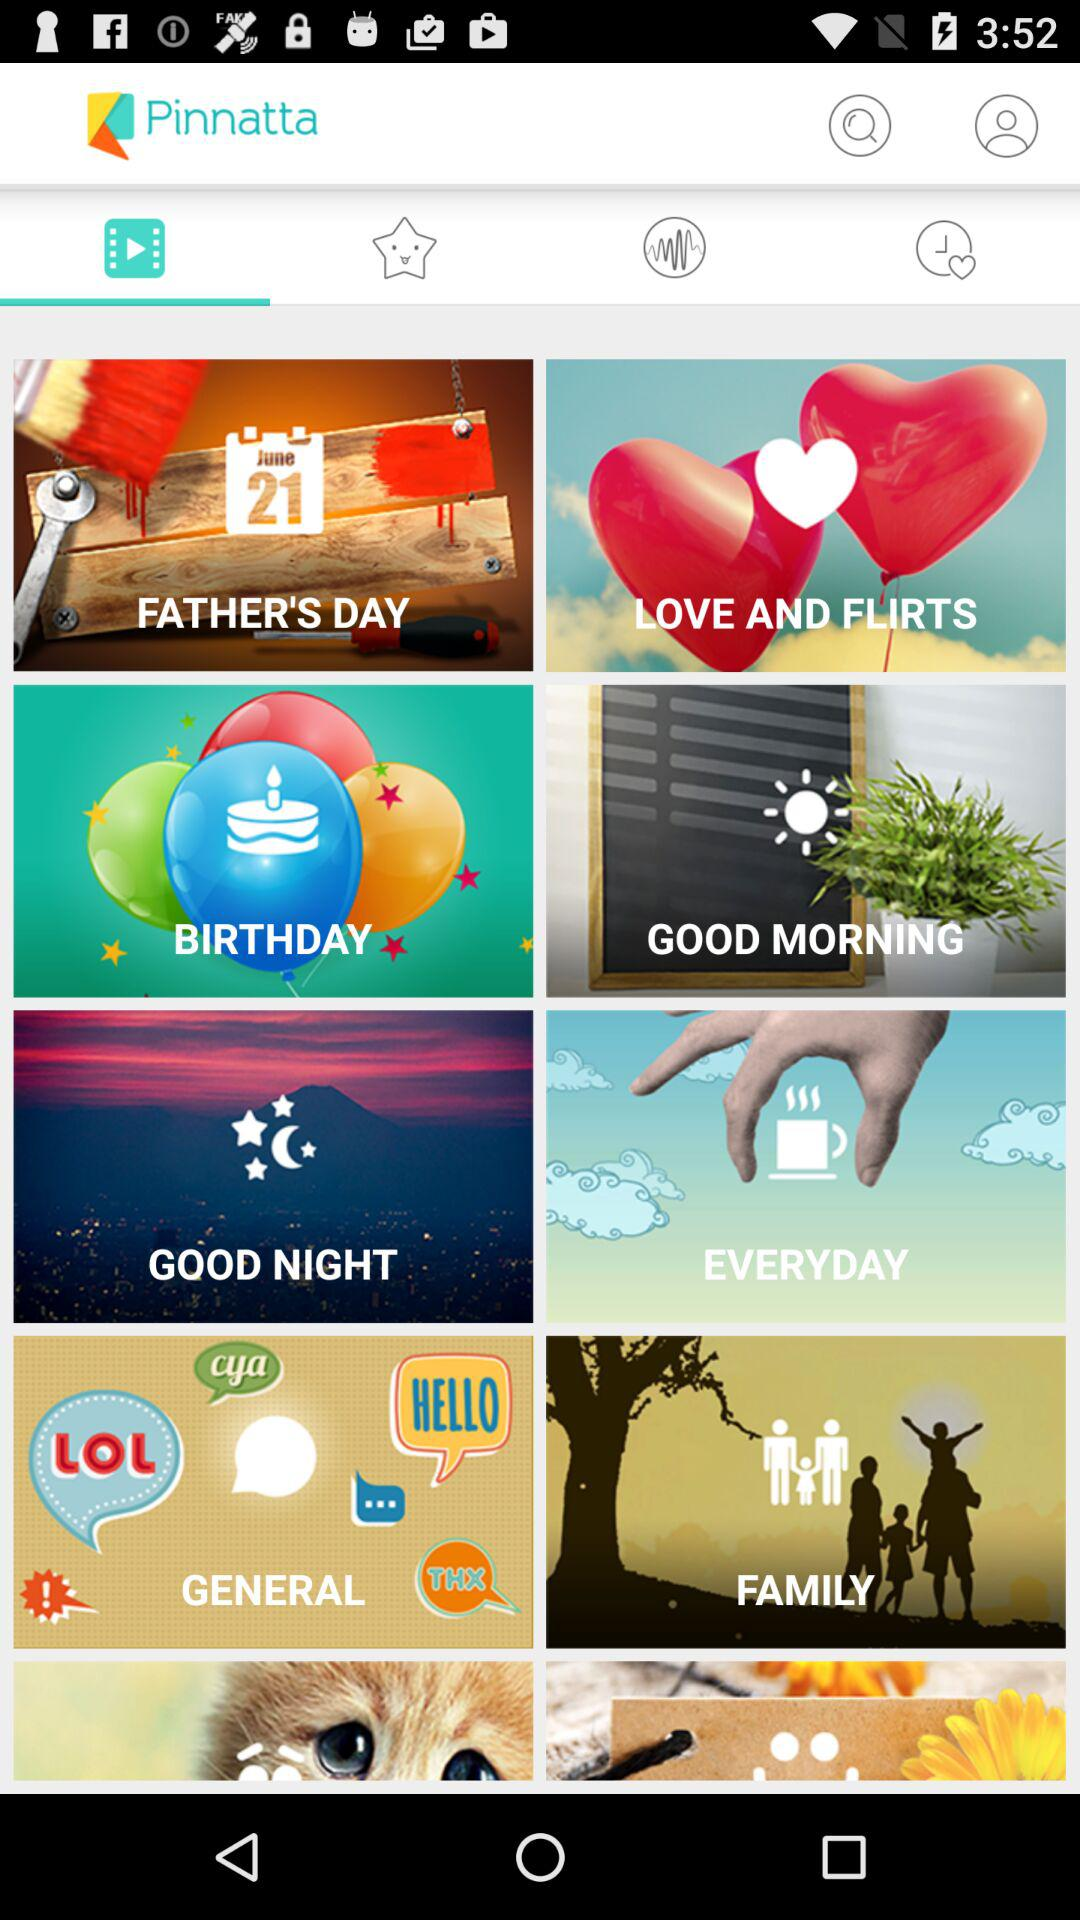Which tab is currently selected? The currently selected tab is "Videos". 